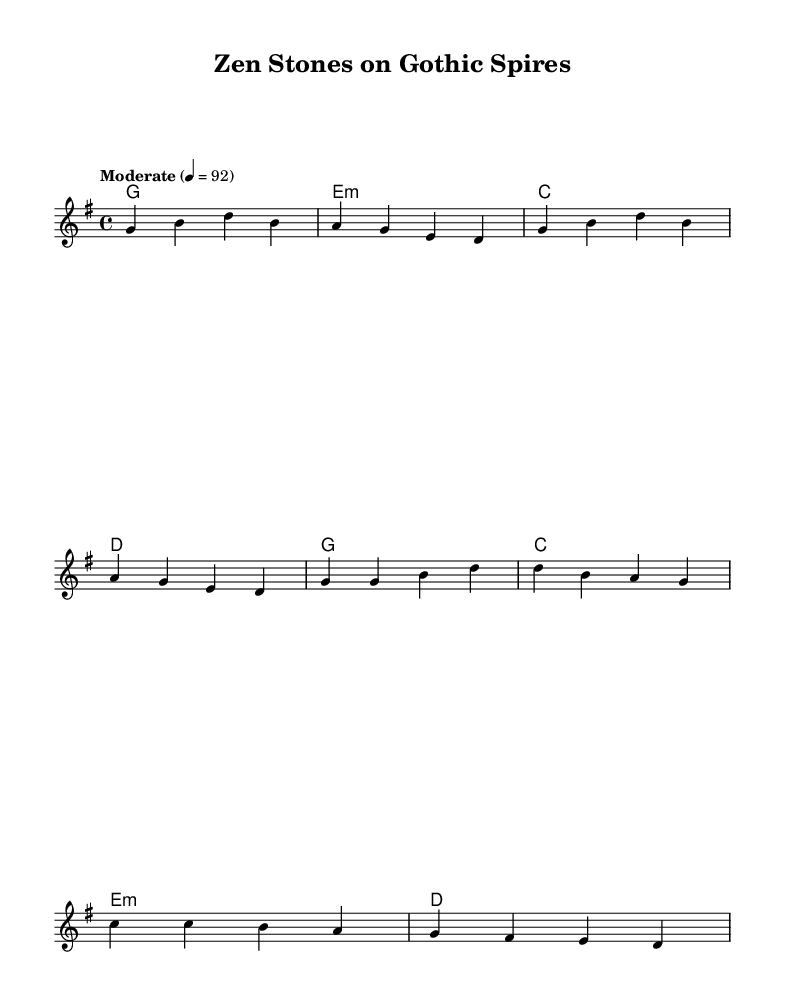What is the key signature of this music? The key signature is indicated at the beginning of the score, with one sharp, which is characteristic of D major or B minor. However, since the melody and harmonies revolve around G major chords, the key signature can be concluded as G major.
Answer: G major What is the time signature of this piece? The time signature is shown at the start of the score, indicating the rhythmic structure. It is written as "4/4," which means there are four beats in each measure and a quarter note gets one beat.
Answer: 4/4 What is the tempo marking given for the piece? The tempo marking is presented directly below the header and specifies the speed of the piece. It indicates a moderate pace with a metronome marking of 92 beats per minute.
Answer: Moderate 4 = 92 How many measures are in the verse section? By analyzing the verse melody section, we can count the number of measures which are noted using bar lines. The verse contains a total of four measures.
Answer: 4 What musical elements reflect the Country Rock genre present in the piece? To identify the elements that reflect the Country Rock genre, we analyze the structure, which includes a simple chord progression, repetitive lyrical themes, and traditional instrumentation typical of the genre. This includes the use of straightforward harmonies and a melodic style that evokes nostalgia.
Answer: Chord progression, repetitive lyrics, traditional instrumentation What is the main theme of the lyrics in the verse? The lyrics in the verse reflect themes of ancient wisdom and spirituality, specifically connecting Buddhist concepts with European architecture, suggesting a blend of cultures and artistic influences. The words "ancient wisdom," "Buddha's smile," and "East meets West" highlight this theme.
Answer: Ancient wisdom and cultural connection 